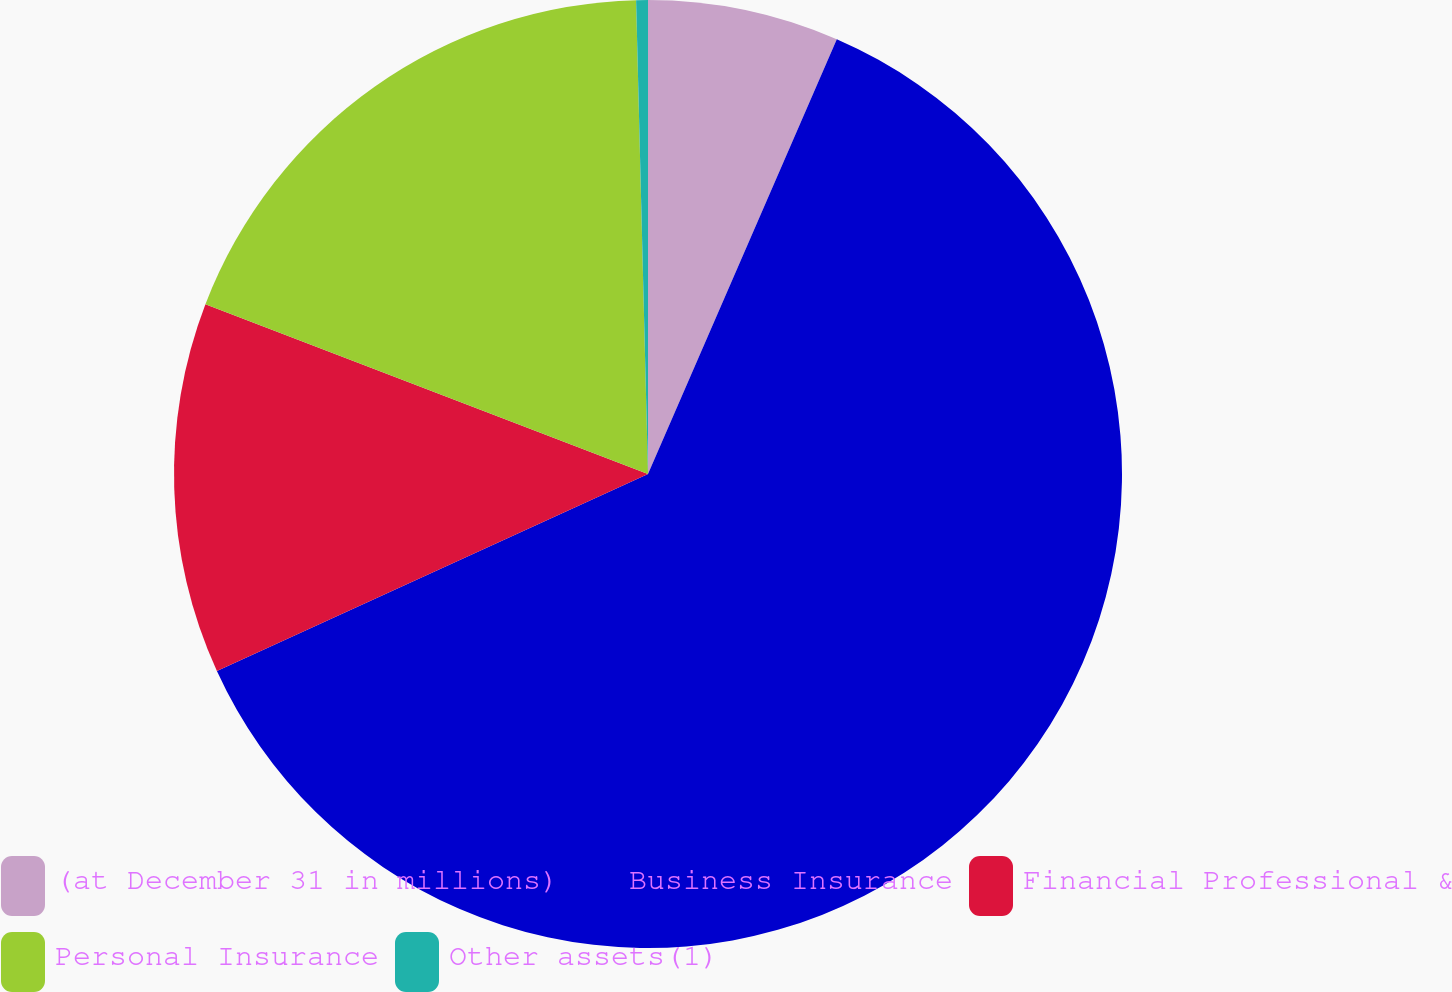Convert chart. <chart><loc_0><loc_0><loc_500><loc_500><pie_chart><fcel>(at December 31 in millions)<fcel>Business Insurance<fcel>Financial Professional &<fcel>Personal Insurance<fcel>Other assets(1)<nl><fcel>6.52%<fcel>61.65%<fcel>12.65%<fcel>18.77%<fcel>0.4%<nl></chart> 